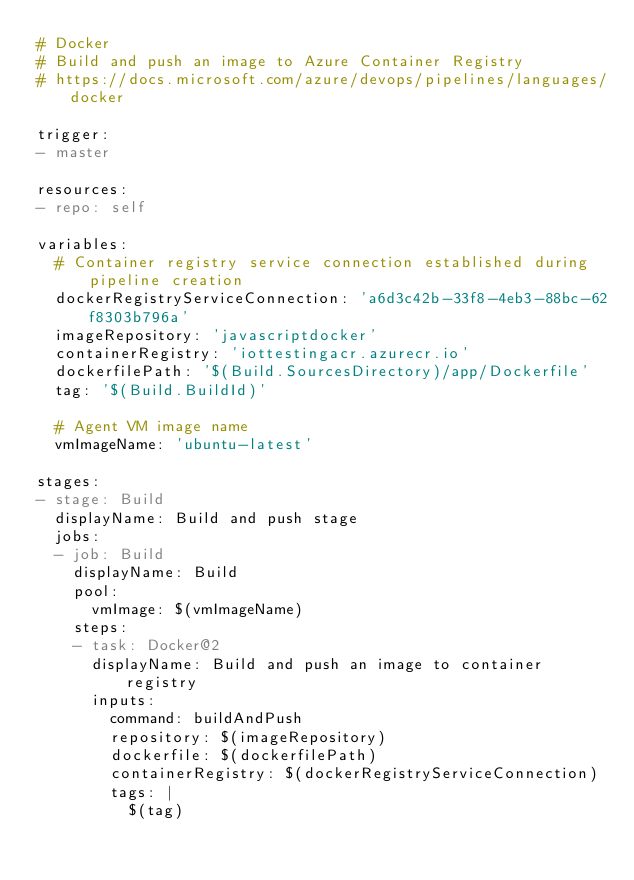<code> <loc_0><loc_0><loc_500><loc_500><_YAML_># Docker
# Build and push an image to Azure Container Registry
# https://docs.microsoft.com/azure/devops/pipelines/languages/docker

trigger:
- master

resources:
- repo: self

variables:
  # Container registry service connection established during pipeline creation
  dockerRegistryServiceConnection: 'a6d3c42b-33f8-4eb3-88bc-62f8303b796a'
  imageRepository: 'javascriptdocker'
  containerRegistry: 'iottestingacr.azurecr.io'
  dockerfilePath: '$(Build.SourcesDirectory)/app/Dockerfile'
  tag: '$(Build.BuildId)'

  # Agent VM image name
  vmImageName: 'ubuntu-latest'

stages:
- stage: Build
  displayName: Build and push stage
  jobs:
  - job: Build
    displayName: Build
    pool:
      vmImage: $(vmImageName)
    steps:
    - task: Docker@2
      displayName: Build and push an image to container registry
      inputs:
        command: buildAndPush
        repository: $(imageRepository)
        dockerfile: $(dockerfilePath)
        containerRegistry: $(dockerRegistryServiceConnection)
        tags: |
          $(tag)
</code> 